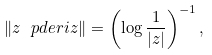<formula> <loc_0><loc_0><loc_500><loc_500>\left \| z \ p d e r i { z } \right \| = \left ( \log \frac { 1 } { | z | } \right ) ^ { - 1 } ,</formula> 